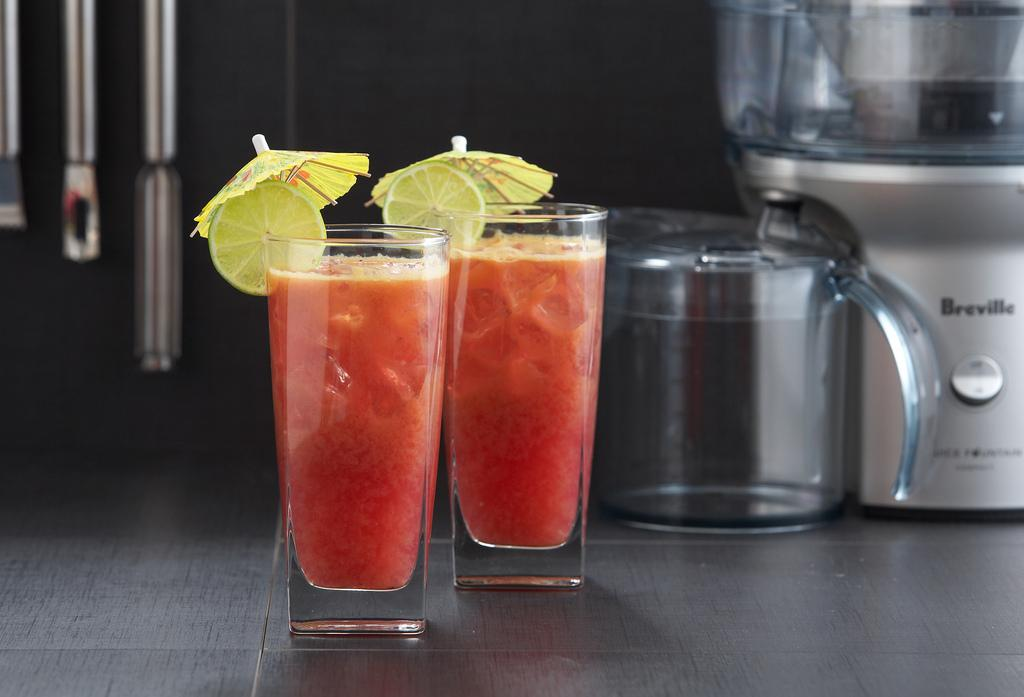<image>
Create a compact narrative representing the image presented. Two tropical fruity drinks are in front of a Breville blender. 